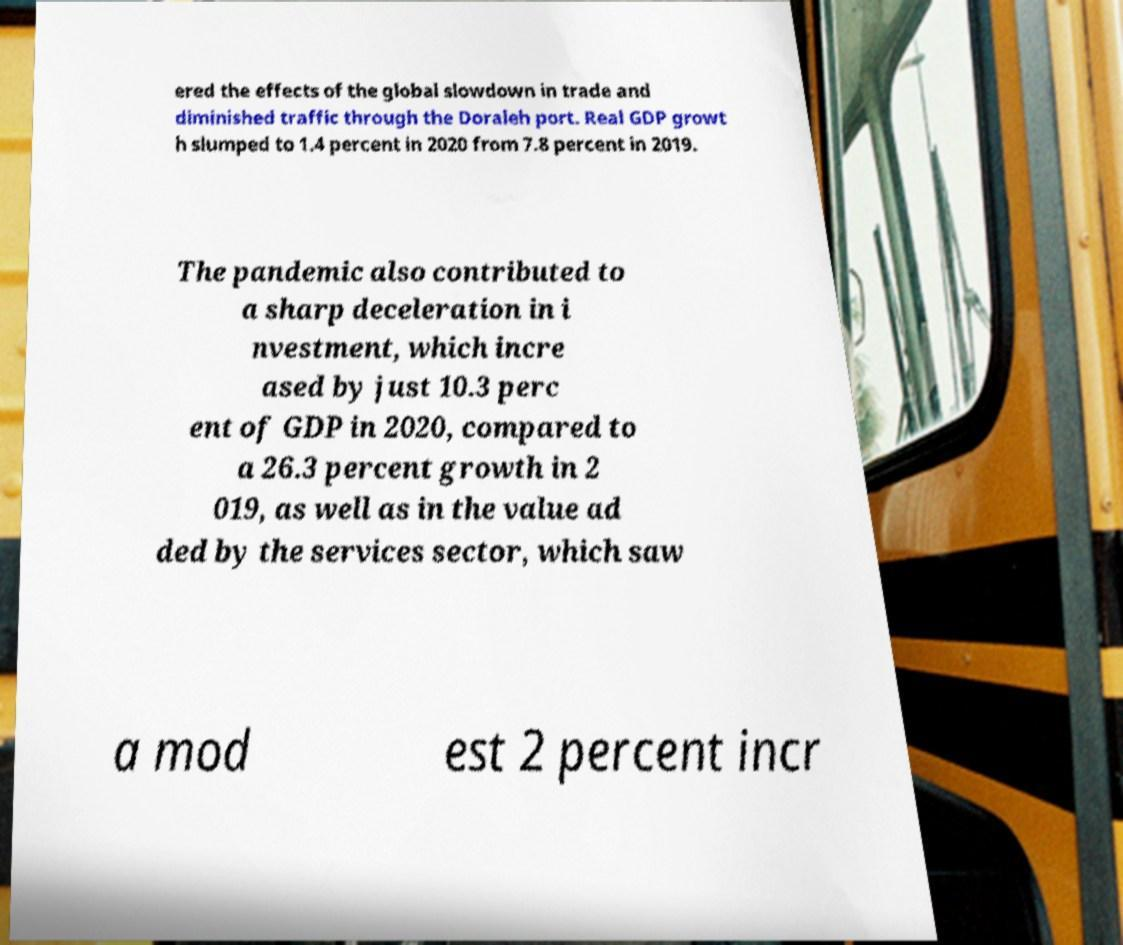Please read and relay the text visible in this image. What does it say? ered the effects of the global slowdown in trade and diminished traffic through the Doraleh port. Real GDP growt h slumped to 1.4 percent in 2020 from 7.8 percent in 2019. The pandemic also contributed to a sharp deceleration in i nvestment, which incre ased by just 10.3 perc ent of GDP in 2020, compared to a 26.3 percent growth in 2 019, as well as in the value ad ded by the services sector, which saw a mod est 2 percent incr 